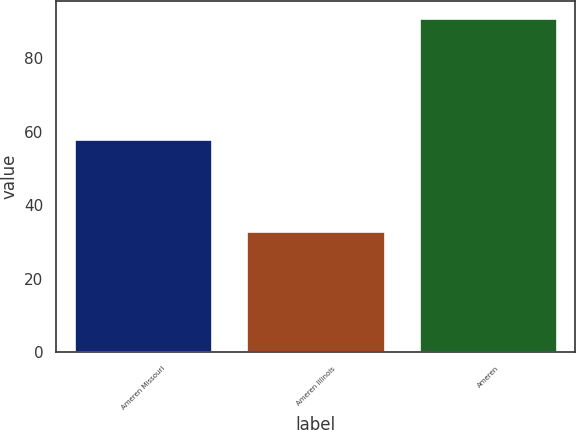Convert chart. <chart><loc_0><loc_0><loc_500><loc_500><bar_chart><fcel>Ameren Missouri<fcel>Ameren Illinois<fcel>Ameren<nl><fcel>58<fcel>33<fcel>91<nl></chart> 